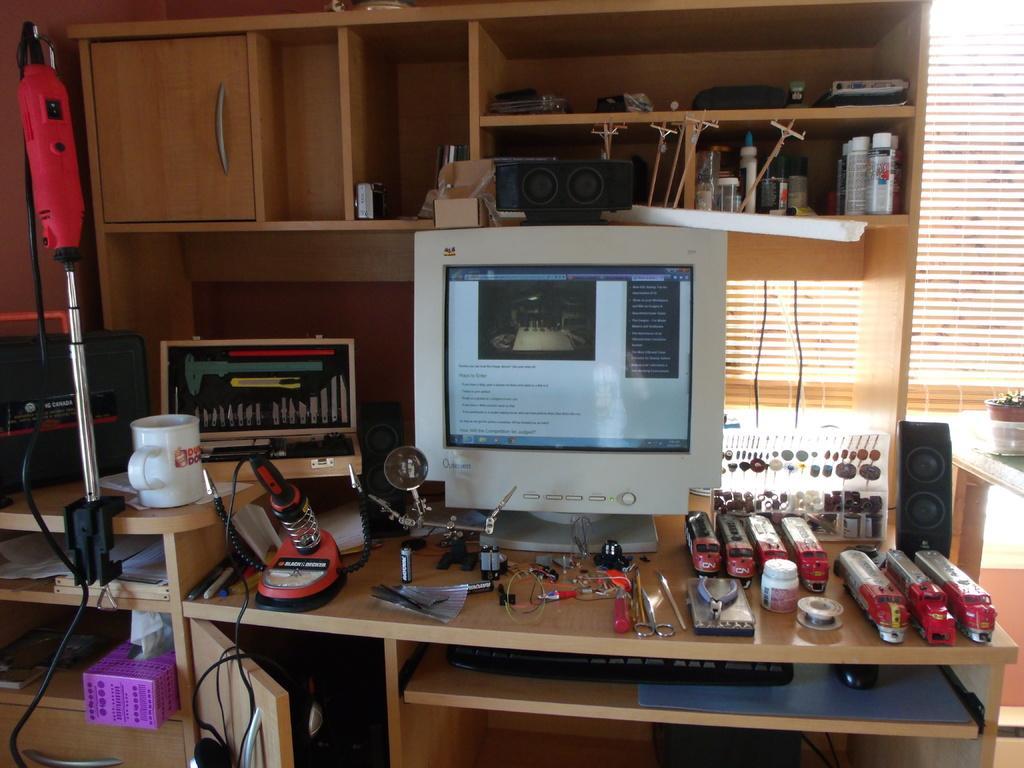Please provide a concise description of this image. In this image in the center there is table and on the table there is a monitor, there are toys, there is a cup and there is an equipment and under the table, there is a keyboard, there is a mouse and there is a CPU and there are wires and on the top of the monitor there is an object which is black in colour and on the wall there is a wardrobe and in the wardrobe there are objects which are black and white in colour. In the background there is a window. On the right there is a table, on the table there is a pot and there is a speaker on the table which is in the center. 